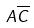<formula> <loc_0><loc_0><loc_500><loc_500>A \overline { C }</formula> 